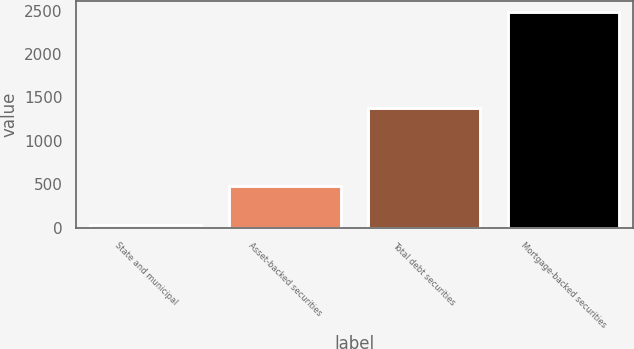<chart> <loc_0><loc_0><loc_500><loc_500><bar_chart><fcel>State and municipal<fcel>Asset-backed securities<fcel>Total debt securities<fcel>Mortgage-backed securities<nl><fcel>34<fcel>478<fcel>1384<fcel>2484<nl></chart> 